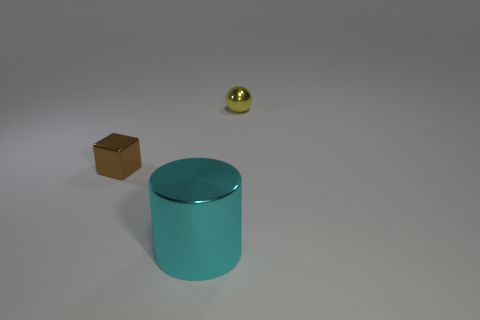Add 3 tiny yellow metal objects. How many objects exist? 6 Subtract all spheres. How many objects are left? 2 Subtract all tiny gray shiny things. Subtract all brown objects. How many objects are left? 2 Add 2 yellow things. How many yellow things are left? 3 Add 2 big shiny cylinders. How many big shiny cylinders exist? 3 Subtract 0 yellow cylinders. How many objects are left? 3 